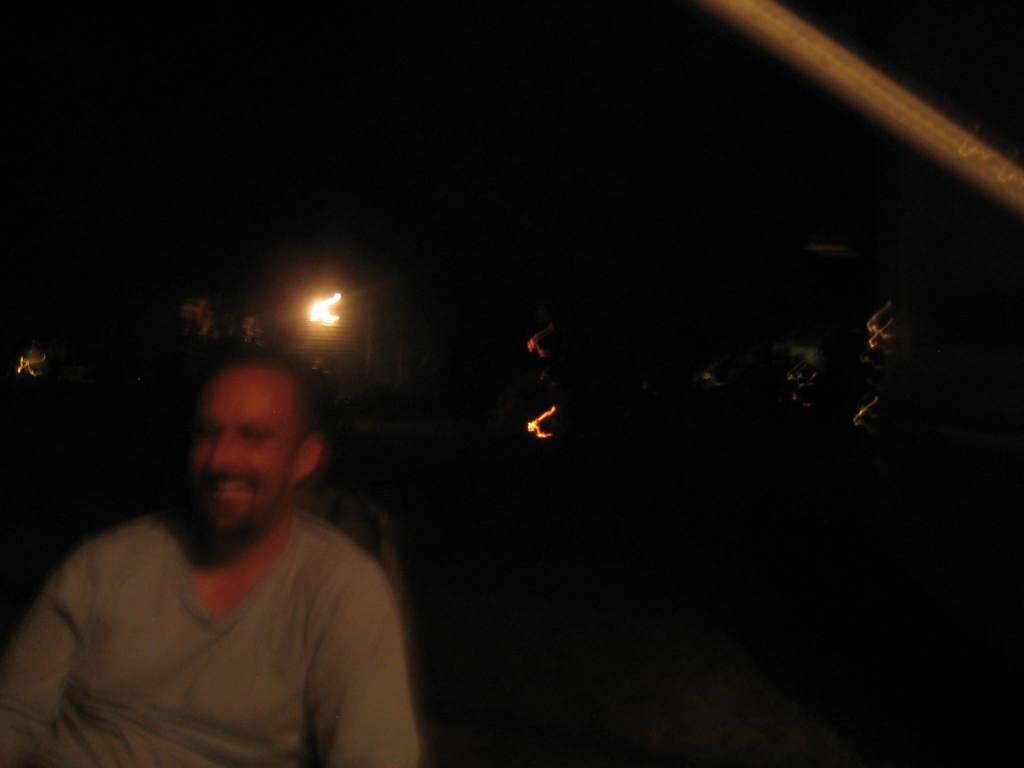How many people are in the foreground of the image? There are two persons sitting in the foreground of the image. What can be seen in the background of the image? There are lights and trees in the background of the image. What is the tall, vertical object visible at the top of the image? There is a pole visible at the top of the image. What type of orange is being used as a bat in the image? There is no orange or bat present in the image. 